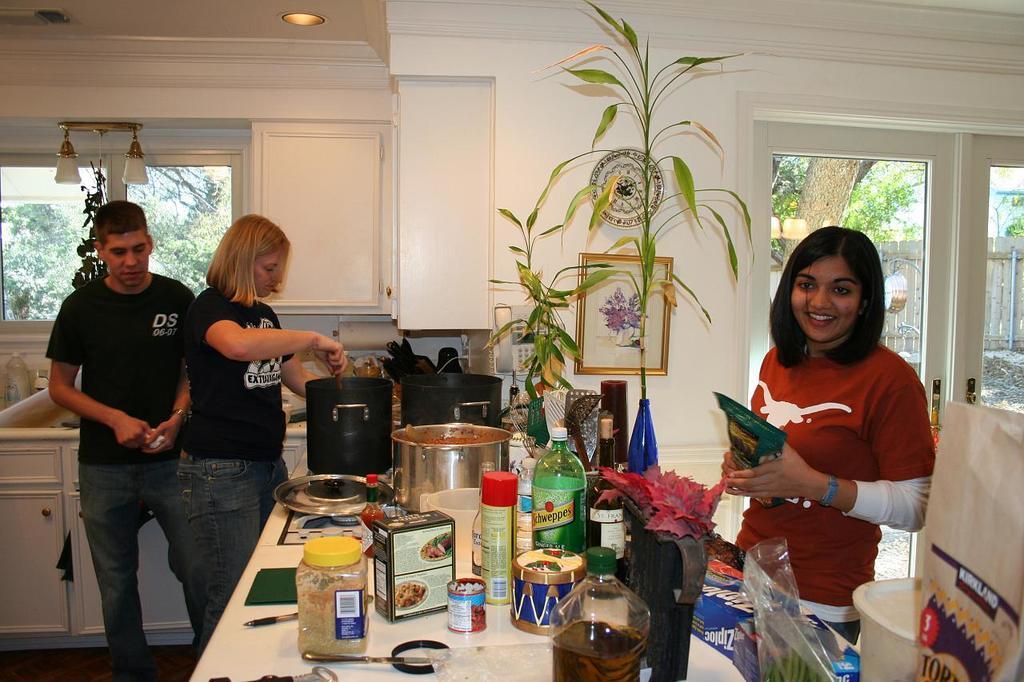Describe this image in one or two sentences. In this image there is a man standing , a woman standing and doing something , a woman standing and smiling by holding a packet and there is a table in that there are box, cardboard box, tin, spray ,bottle, drum, magnifying glass,pen , jar and there is a photo frame attached to the wall , plant inside the room , lamp attached to the wall ,light attached to the ceiling ,tree , building and wooden fence. 